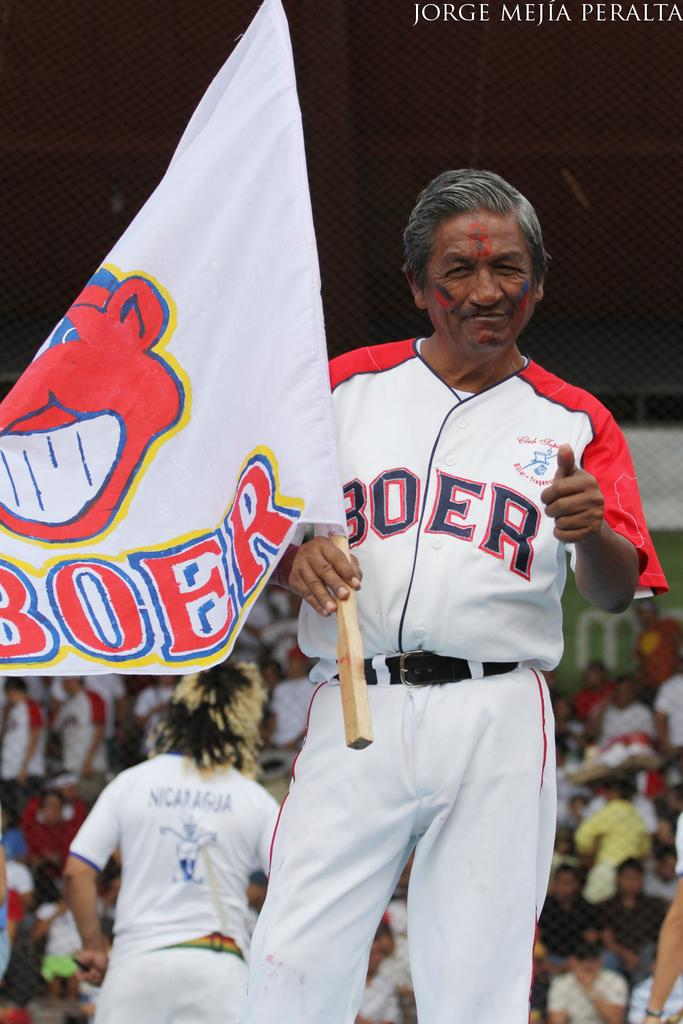Provide a one-sentence caption for the provided image. a man holding up a Boer flag and in a Boer jersey. 